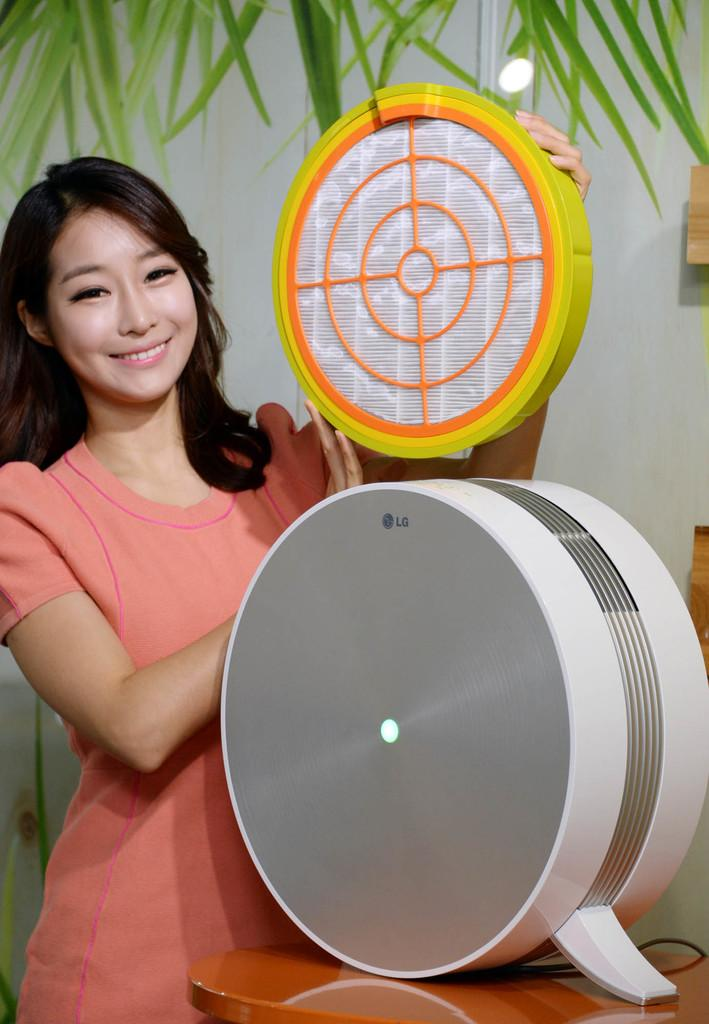Who is present in the image? There is a woman in the image. What expression does the woman have? The woman is smiling. What can be seen in the image besides the woman? There is a table in the image, and there are objects on the table. What is visible in the background of the image? There is a wall and leaves visible in the background of the image. What type of wax is being used to create the chain on the horn in the image? There is no wax, chain, or horn present in the image. 